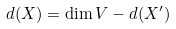<formula> <loc_0><loc_0><loc_500><loc_500>d ( X ) = \dim V - d ( X ^ { \prime } )</formula> 